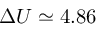<formula> <loc_0><loc_0><loc_500><loc_500>\Delta U \simeq 4 . 8 6</formula> 